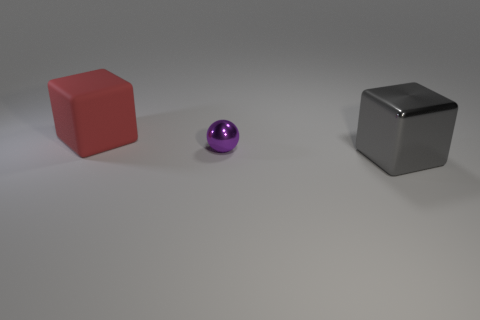Add 2 tiny red metal objects. How many objects exist? 5 Subtract all blocks. How many objects are left? 1 Add 1 metallic cylinders. How many metallic cylinders exist? 1 Subtract 0 brown cylinders. How many objects are left? 3 Subtract all small brown shiny things. Subtract all small objects. How many objects are left? 2 Add 2 large shiny cubes. How many large shiny cubes are left? 3 